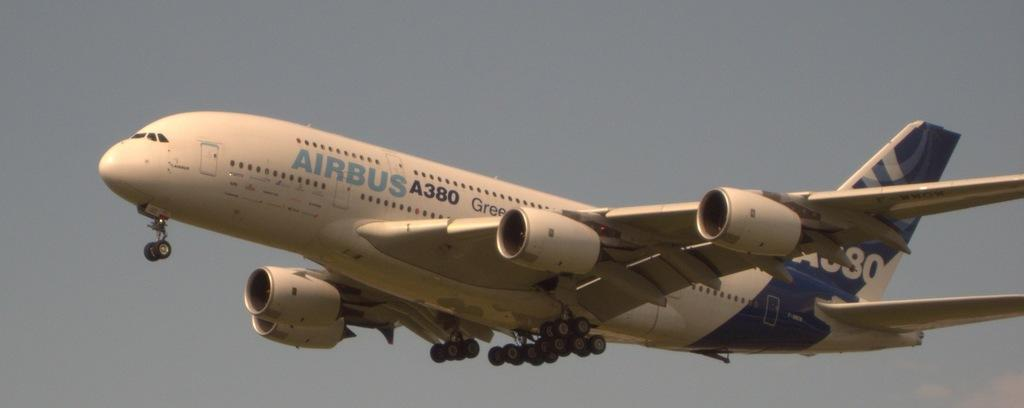<image>
Describe the image concisely. An Airbus 380 jet is in the air. 